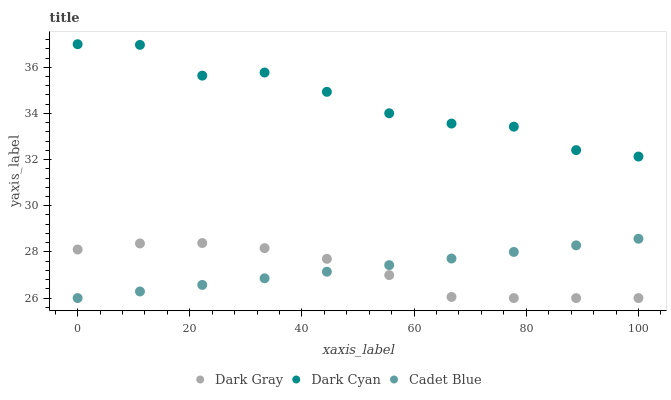Does Dark Gray have the minimum area under the curve?
Answer yes or no. Yes. Does Dark Cyan have the maximum area under the curve?
Answer yes or no. Yes. Does Cadet Blue have the minimum area under the curve?
Answer yes or no. No. Does Cadet Blue have the maximum area under the curve?
Answer yes or no. No. Is Cadet Blue the smoothest?
Answer yes or no. Yes. Is Dark Cyan the roughest?
Answer yes or no. Yes. Is Dark Cyan the smoothest?
Answer yes or no. No. Is Cadet Blue the roughest?
Answer yes or no. No. Does Dark Gray have the lowest value?
Answer yes or no. Yes. Does Dark Cyan have the lowest value?
Answer yes or no. No. Does Dark Cyan have the highest value?
Answer yes or no. Yes. Does Cadet Blue have the highest value?
Answer yes or no. No. Is Dark Gray less than Dark Cyan?
Answer yes or no. Yes. Is Dark Cyan greater than Cadet Blue?
Answer yes or no. Yes. Does Dark Gray intersect Cadet Blue?
Answer yes or no. Yes. Is Dark Gray less than Cadet Blue?
Answer yes or no. No. Is Dark Gray greater than Cadet Blue?
Answer yes or no. No. Does Dark Gray intersect Dark Cyan?
Answer yes or no. No. 